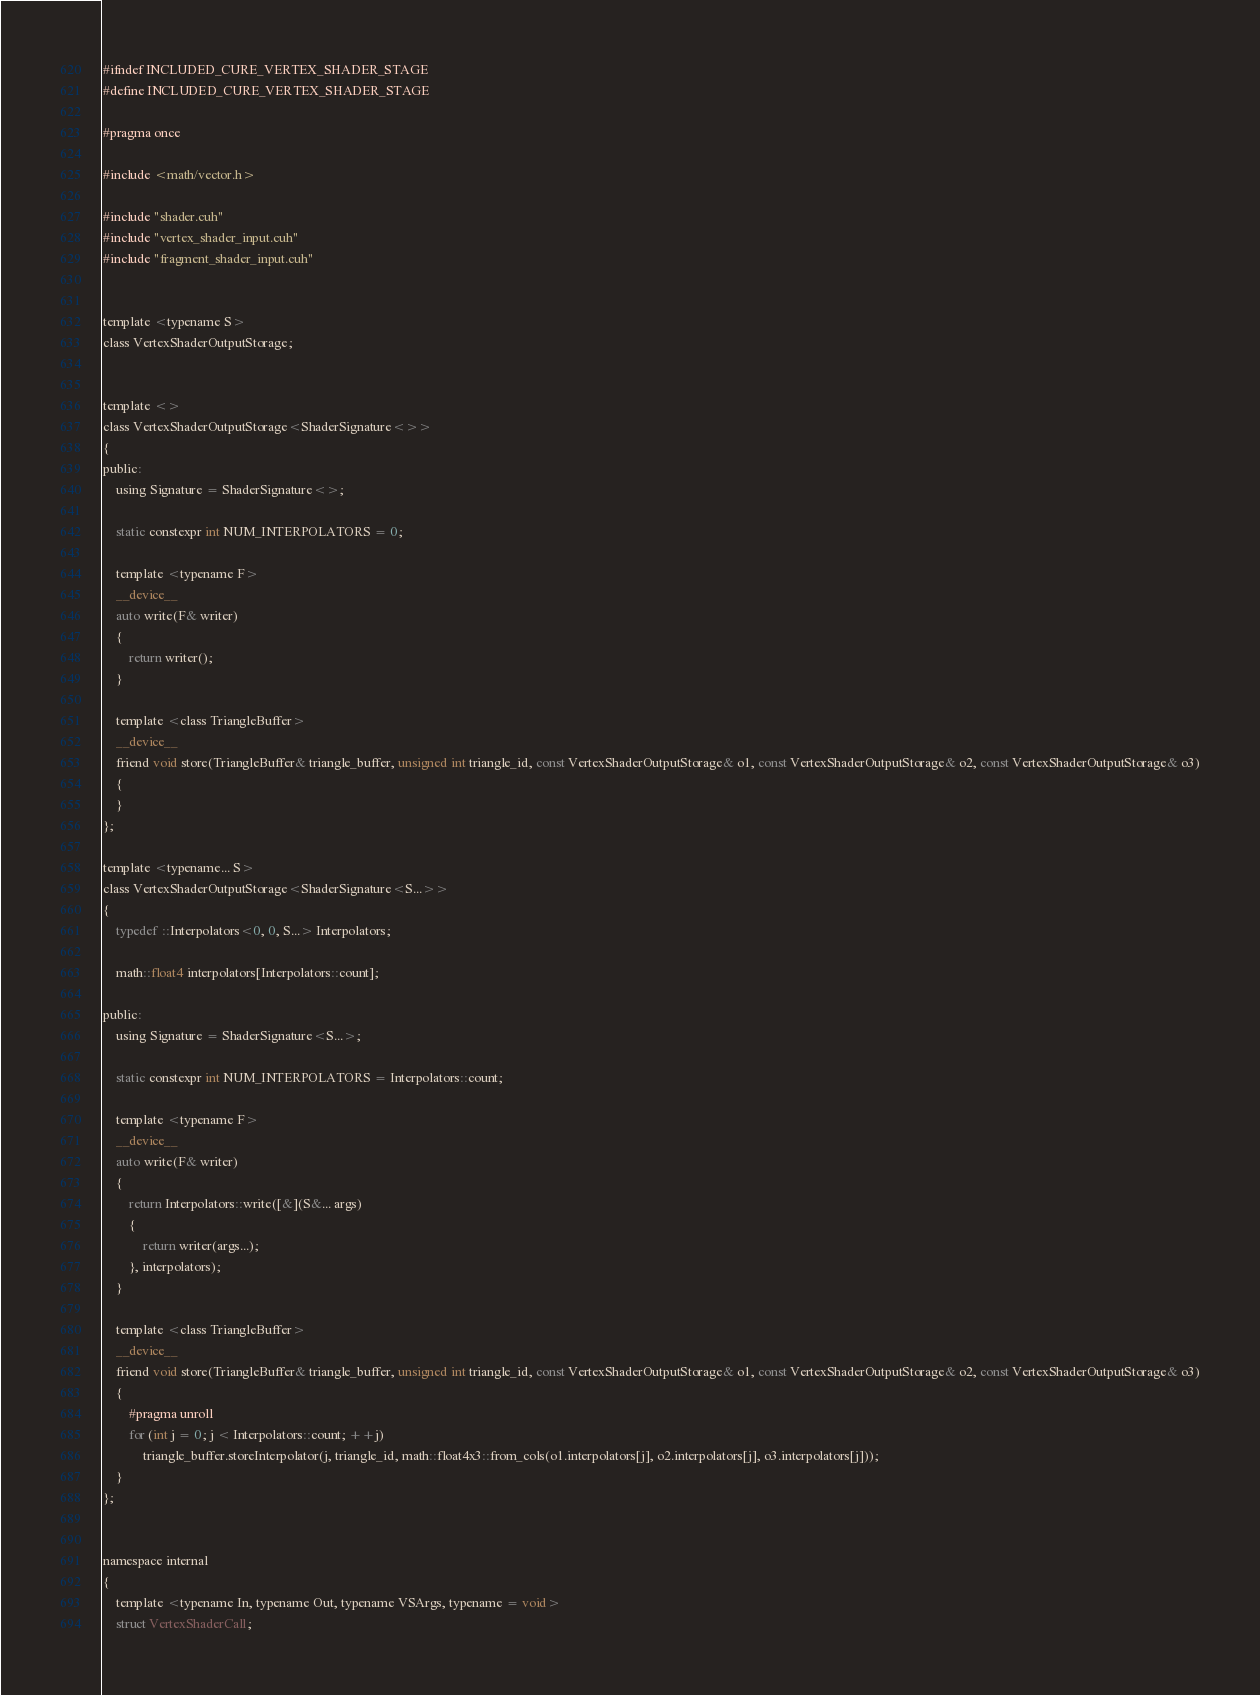Convert code to text. <code><loc_0><loc_0><loc_500><loc_500><_Cuda_>


#ifndef INCLUDED_CURE_VERTEX_SHADER_STAGE
#define INCLUDED_CURE_VERTEX_SHADER_STAGE

#pragma once

#include <math/vector.h>

#include "shader.cuh"
#include "vertex_shader_input.cuh"
#include "fragment_shader_input.cuh"


template <typename S>
class VertexShaderOutputStorage;


template <>
class VertexShaderOutputStorage<ShaderSignature<>>
{
public:
	using Signature = ShaderSignature<>;

	static constexpr int NUM_INTERPOLATORS = 0;

	template <typename F>
	__device__
	auto write(F& writer)
	{
		return writer();
	}

	template <class TriangleBuffer>
	__device__
	friend void store(TriangleBuffer& triangle_buffer, unsigned int triangle_id, const VertexShaderOutputStorage& o1, const VertexShaderOutputStorage& o2, const VertexShaderOutputStorage& o3)
	{
	}
};

template <typename... S>
class VertexShaderOutputStorage<ShaderSignature<S...>>
{
	typedef ::Interpolators<0, 0, S...> Interpolators;

	math::float4 interpolators[Interpolators::count];

public:
	using Signature = ShaderSignature<S...>;

	static constexpr int NUM_INTERPOLATORS = Interpolators::count;

	template <typename F>
	__device__
	auto write(F& writer)
	{
		return Interpolators::write([&](S&... args)
		{
			return writer(args...);
		}, interpolators);
	}

	template <class TriangleBuffer>
	__device__
	friend void store(TriangleBuffer& triangle_buffer, unsigned int triangle_id, const VertexShaderOutputStorage& o1, const VertexShaderOutputStorage& o2, const VertexShaderOutputStorage& o3)
	{
		#pragma unroll
		for (int j = 0; j < Interpolators::count; ++j)
			triangle_buffer.storeInterpolator(j, triangle_id, math::float4x3::from_cols(o1.interpolators[j], o2.interpolators[j], o3.interpolators[j]));
	}
};


namespace internal
{
	template <typename In, typename Out, typename VSArgs, typename = void>
	struct VertexShaderCall;

</code> 